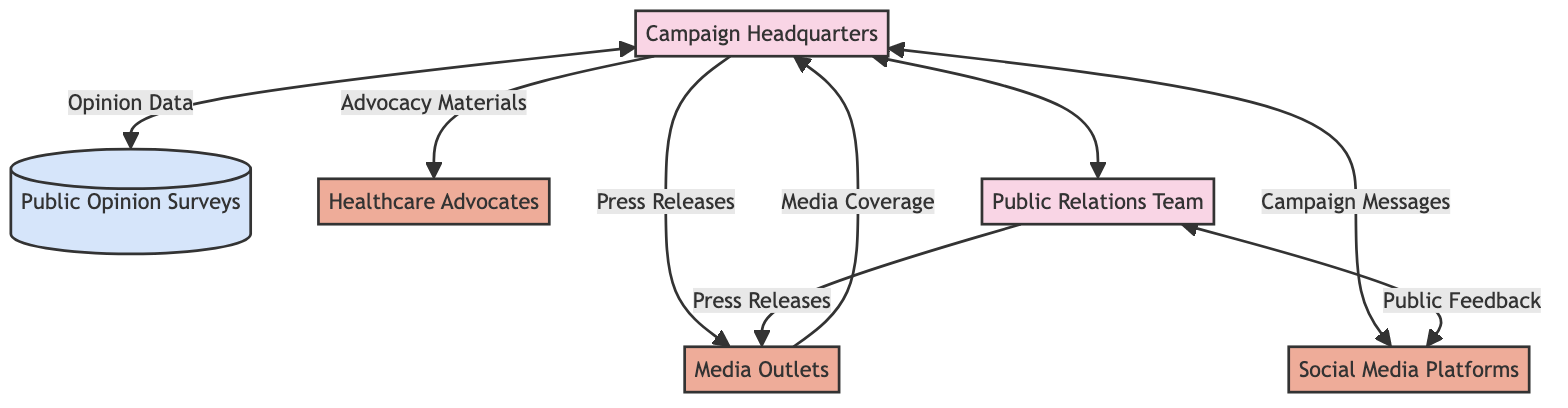What is the primary process in the diagram? The primary process in the diagram is represented as "Campaign Headquarters," which serves as the central hub for designing and coordinating the media and public relations strategy.
Answer: Campaign Headquarters How many external entities are present in the diagram? There are four external entities present: Media Outlets, Healthcare Advocates, Social Media Platforms, and Public Relations Team. This can be identified by counting the labeled external entities shown in the diagram.
Answer: 4 What data flow comes from the Campaign Headquarters to the Media Outlets? The data flow coming from the Campaign Headquarters to the Media Outlets is labeled "Press Releases," which indicates the official statements disseminated to communicate campaign updates.
Answer: Press Releases Which entity receives the "Public Feedback"? The "Public Feedback" is received by the Public Relations Team, which manages the campaign's public image and relations with media. This can be seen in the diagram where the feedback flows into the Public Relations Team.
Answer: Public Relations Team What is the relationship between the "Public Opinion Surveys" and "Campaign Headquarters"? The relationship is that the "Opinion Data" flows from the Public Opinion Surveys to the Campaign Headquarters, suggesting that the campaign uses this data to inform its strategies. This connection indicates data collection and utilization for decision-making.
Answer: Opinion Data How many data flows connect the Campaign Headquarters to other entities? There are five data flows connecting the Campaign Headquarters to other entities, specifically to Media Outlets, Healthcare Advocates, Social Media Platforms, and the Public Relations Team. Recounting these interactions indicates the flow of information.
Answer: 5 What type of materials are provided to Healthcare Advocates? The type of materials provided to Healthcare Advocates is labeled as "Advocacy Materials," which are informational resources designed to support the campaign's messaging efforts. This is explicitly stated in the diagram.
Answer: Advocacy Materials Which process interacts with Social Media Platforms? The process that interacts with Social Media Platforms is the Public Relations Team, as it receives public feedback from social media engagement and also sends campaign messages to Social Media Platforms. This two-way interaction highlights the campaign's engagement strategy.
Answer: Public Relations Team 